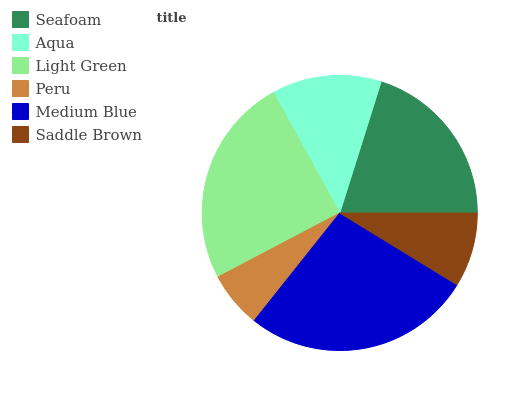Is Peru the minimum?
Answer yes or no. Yes. Is Medium Blue the maximum?
Answer yes or no. Yes. Is Aqua the minimum?
Answer yes or no. No. Is Aqua the maximum?
Answer yes or no. No. Is Seafoam greater than Aqua?
Answer yes or no. Yes. Is Aqua less than Seafoam?
Answer yes or no. Yes. Is Aqua greater than Seafoam?
Answer yes or no. No. Is Seafoam less than Aqua?
Answer yes or no. No. Is Seafoam the high median?
Answer yes or no. Yes. Is Aqua the low median?
Answer yes or no. Yes. Is Saddle Brown the high median?
Answer yes or no. No. Is Peru the low median?
Answer yes or no. No. 